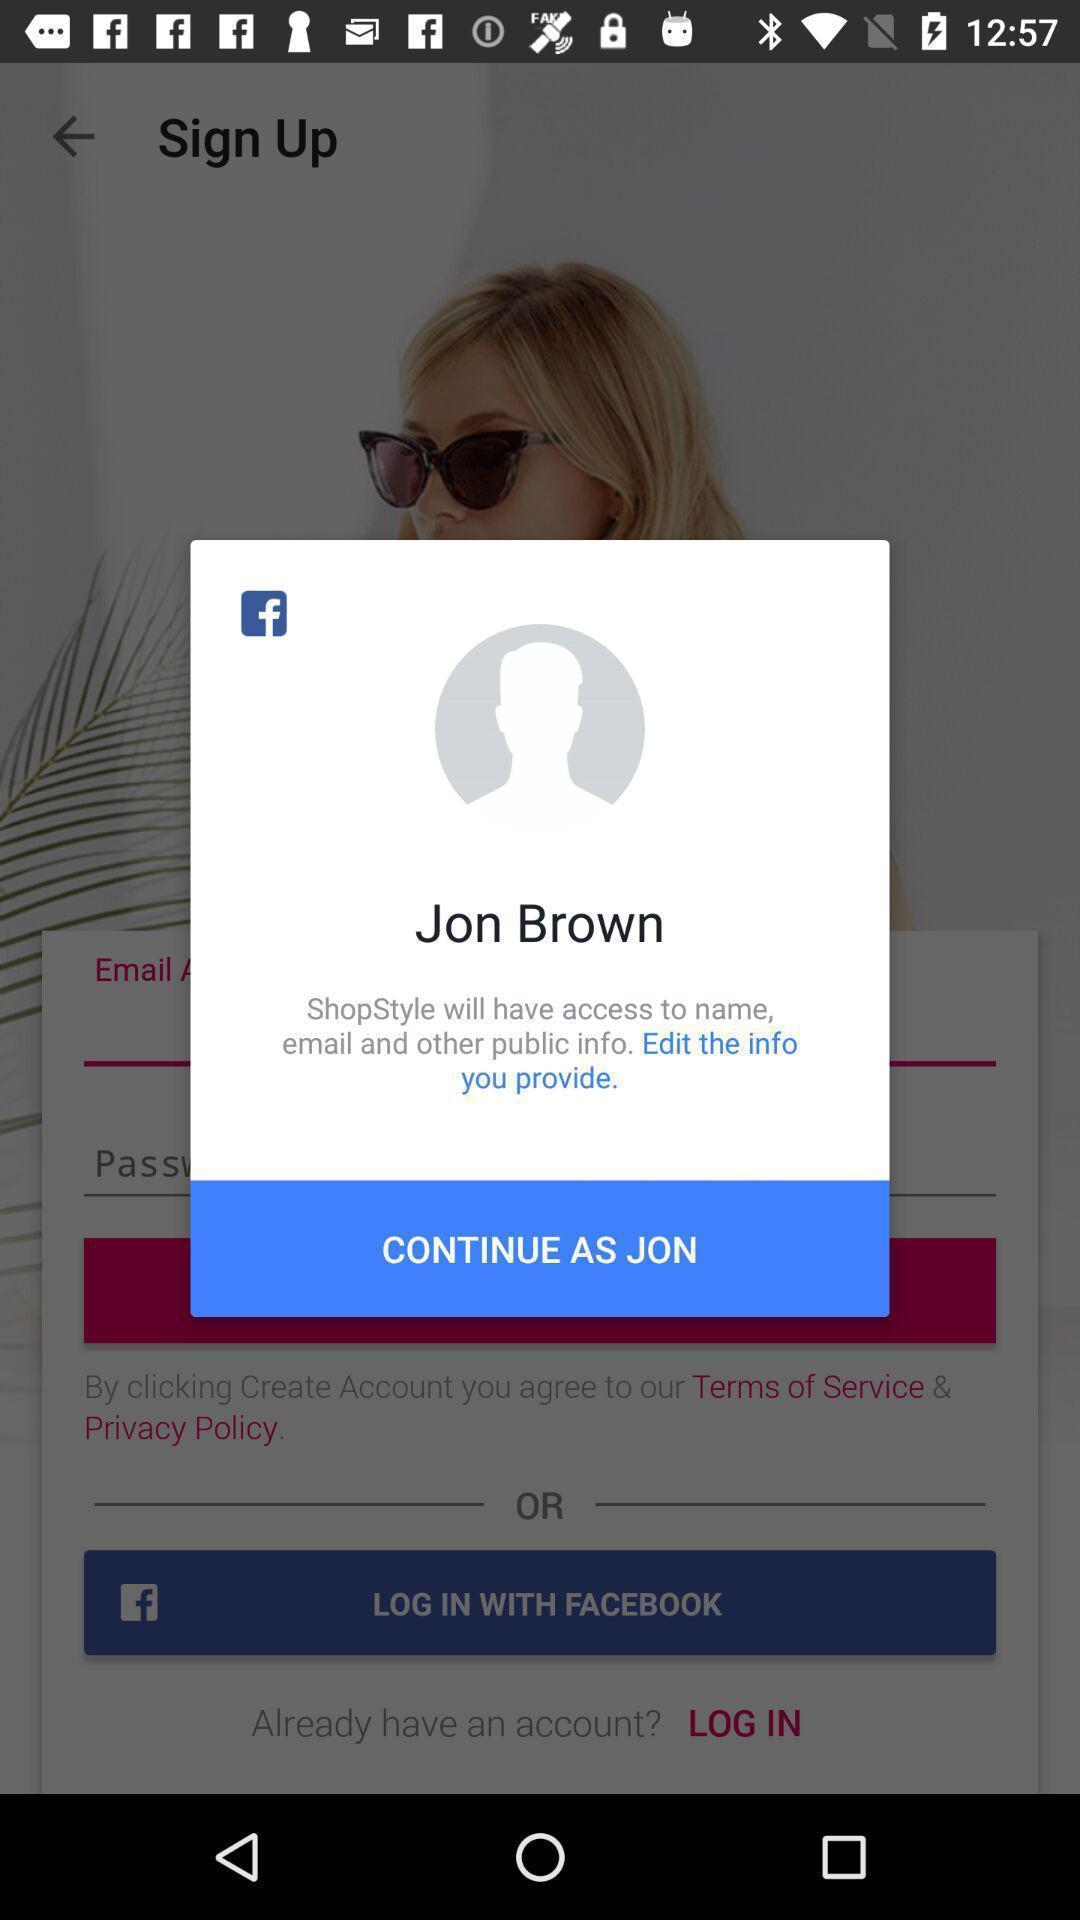Give me a narrative description of this picture. Pop-up showing sign-in page of a social app. 